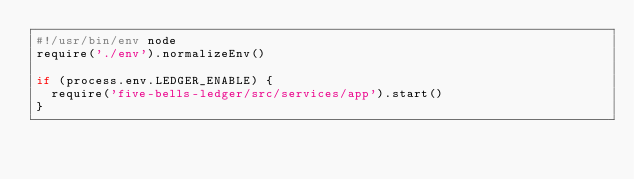<code> <loc_0><loc_0><loc_500><loc_500><_JavaScript_>#!/usr/bin/env node
require('./env').normalizeEnv()

if (process.env.LEDGER_ENABLE) {
  require('five-bells-ledger/src/services/app').start()
}
</code> 